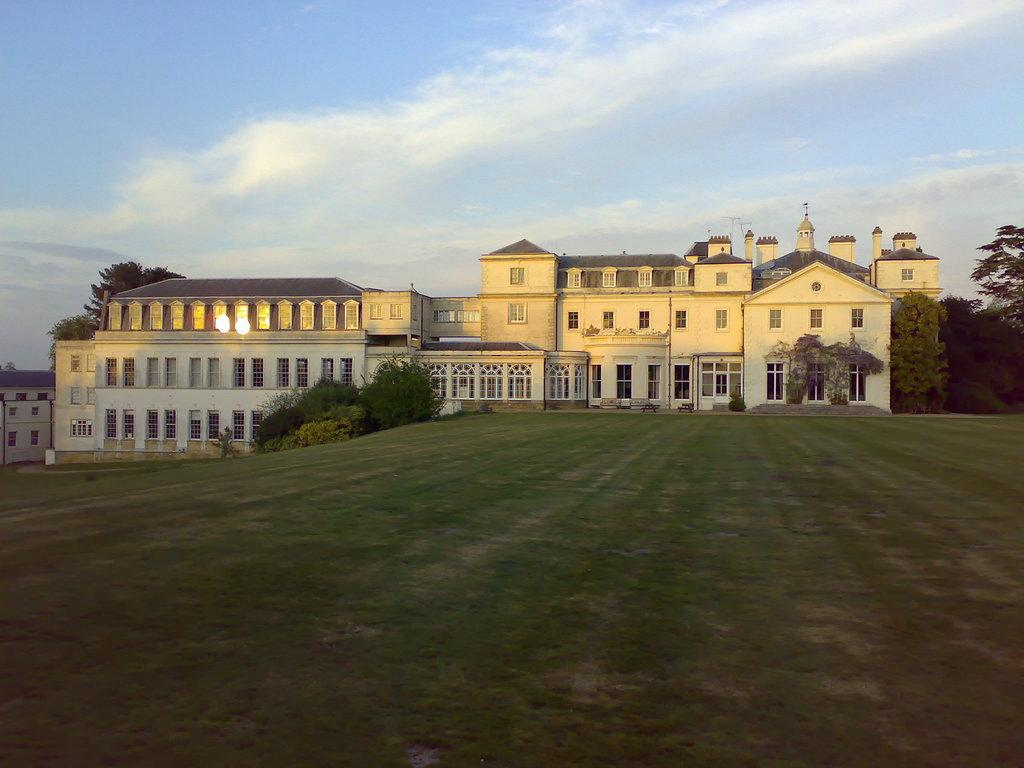What type of structures are present in the image? There are buildings in the image. What type of vegetation can be seen in the image? There are trees, plants, and grass in the image. What architectural features are visible in the image? There are windows and walls in the image. What part of the natural environment is visible in the image? The sky is visible in the background of the image. What type of zipper can be seen on the lawyer's suit in the image? There is no lawyer or zipper present in the image. What type of drug is being discussed by the people in the image? There is no discussion of drugs or people present in the image. 